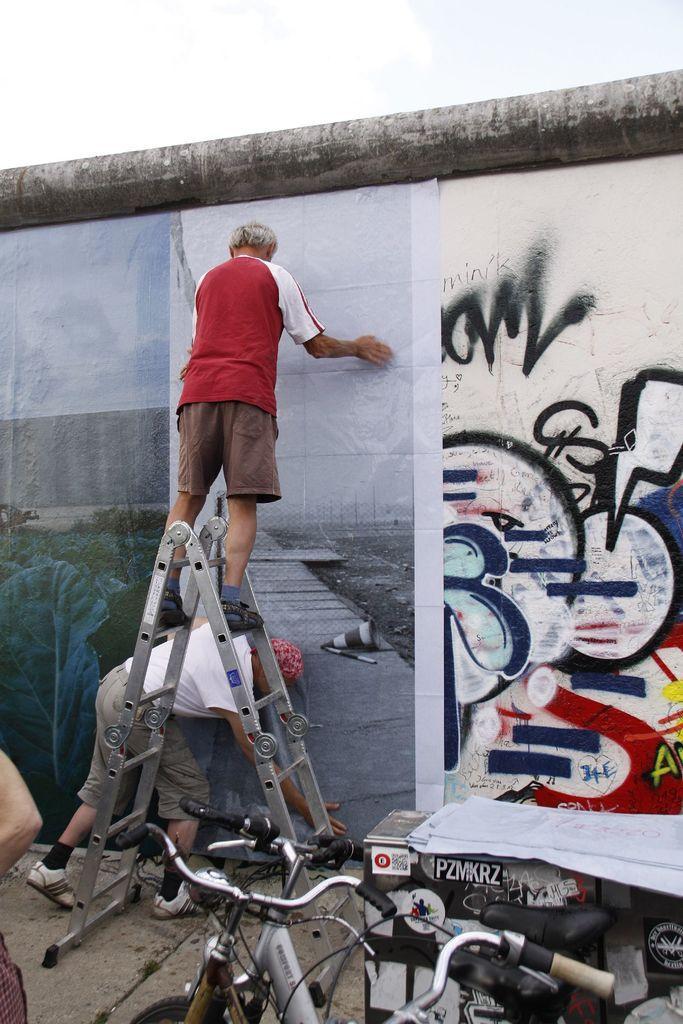Describe this image in one or two sentences. In this picture I can see two persons, there is a person standing on the ladder, there are bicycles, there are papers on the table, there is a poster on the wall and there are some scribblings on the wall, and in the background there is sky. 